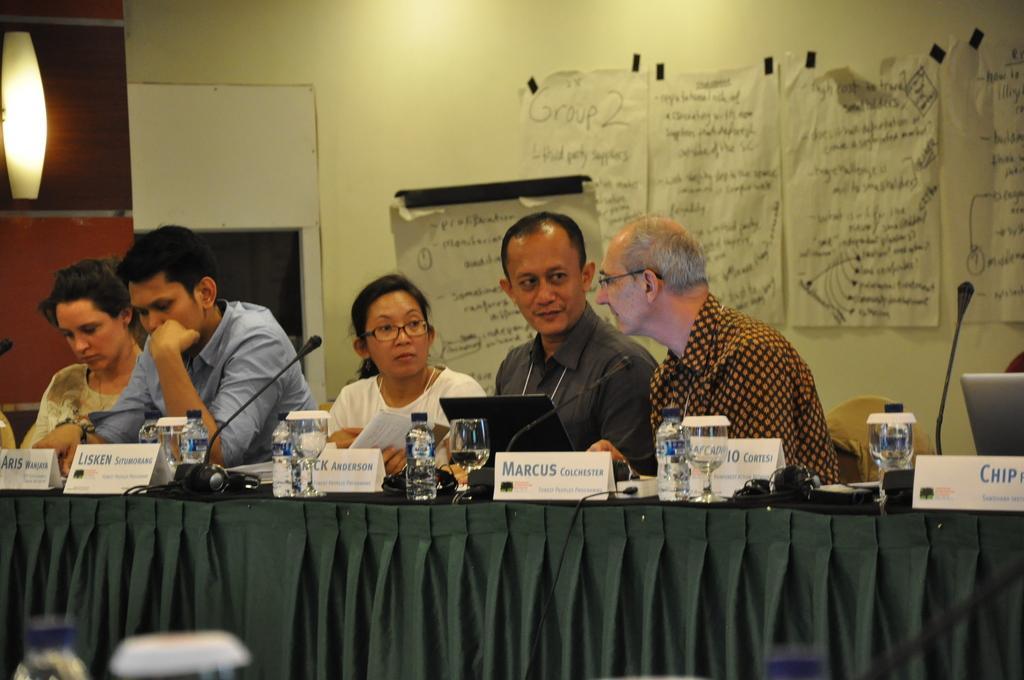How would you summarize this image in a sentence or two? In the image we can see there are five people, three men and two women they are wearing clothes and two of them are wearing spectacles. It looks like they are talking to each other. Here we can see the chair and the table. On the table we can see wine glass, water bottle, name plate, system and microphones. Here we can see the curtains and behind them, we can see the posts stick to the wall. 